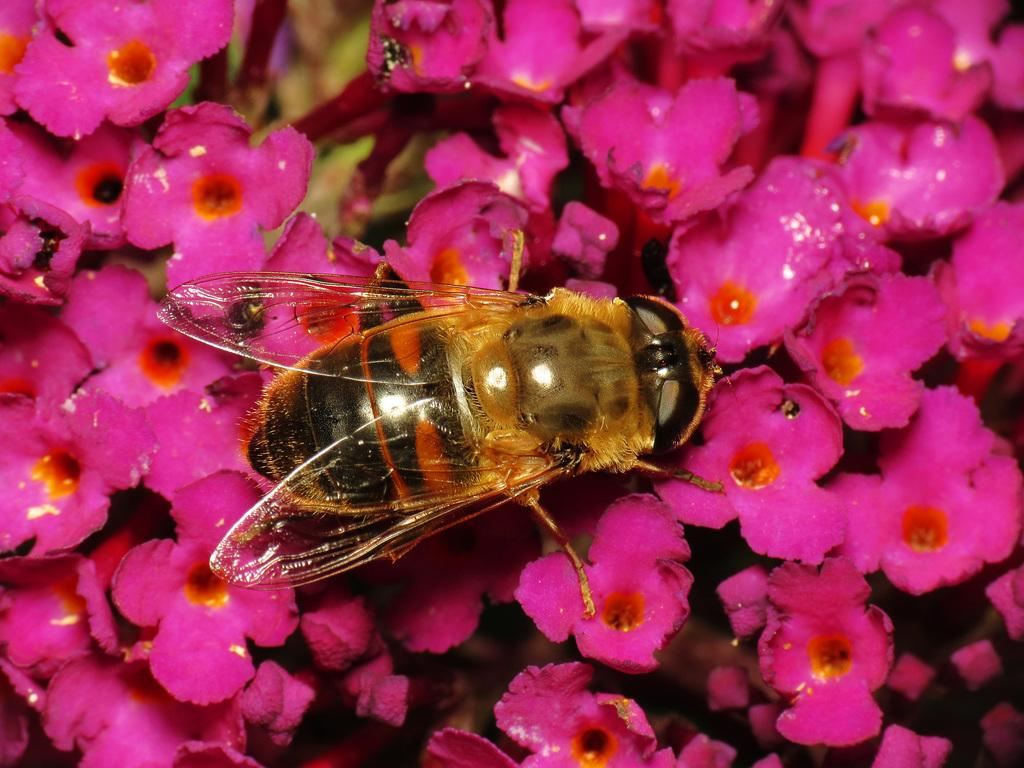What type of flowers can be seen in the image? There are pink color flowers in the image. Can you describe any other living organisms present in the image? Yes, there is an insect with wings in the image. What type of work does the insect perform in the image? There is no indication in the image that the insect is performing any work. 